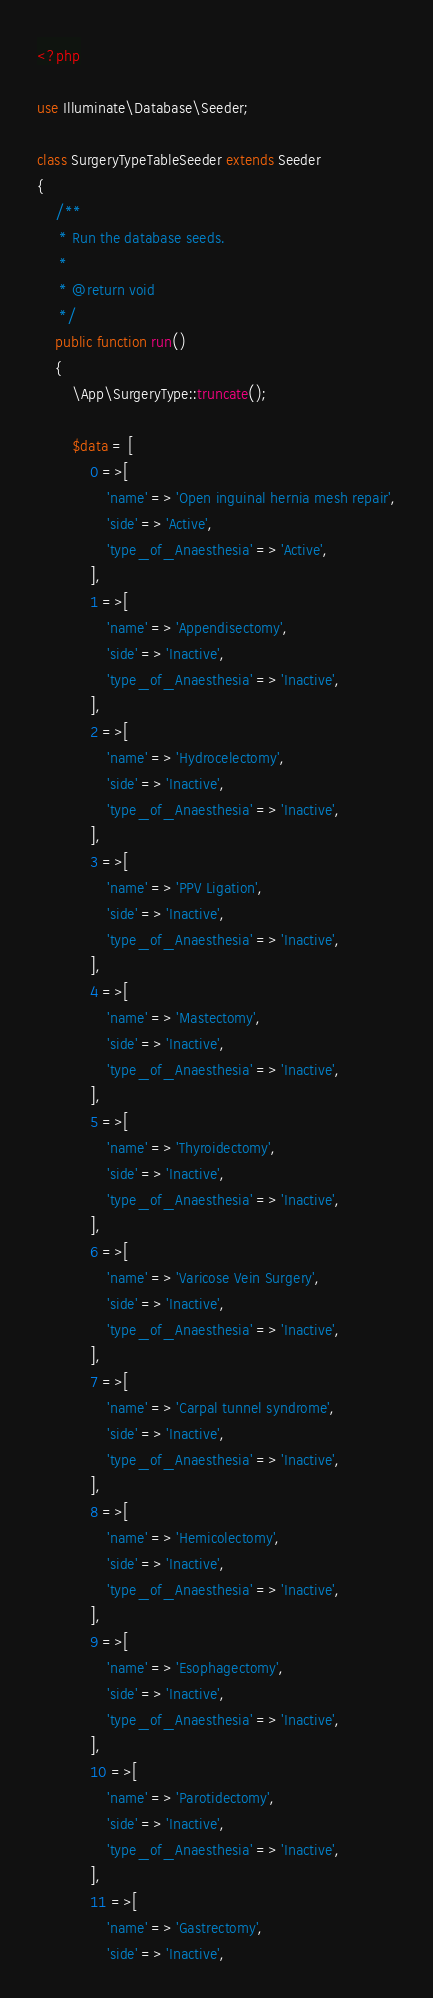<code> <loc_0><loc_0><loc_500><loc_500><_PHP_><?php

use Illuminate\Database\Seeder;

class SurgeryTypeTableSeeder extends Seeder
{
    /**
     * Run the database seeds.
     *
     * @return void
     */
    public function run()
    {
        \App\SurgeryType::truncate();

        $data = [
            0 =>[
                'name' => 'Open inguinal hernia mesh repair',
                'side' => 'Active',
                'type_of_Anaesthesia' => 'Active',
            ],
            1 =>[
                'name' => 'Appendisectomy',
                'side' => 'Inactive',
                'type_of_Anaesthesia' => 'Inactive',
            ],
            2 =>[
                'name' => 'Hydrocelectomy',
                'side' => 'Inactive',
                'type_of_Anaesthesia' => 'Inactive',
            ],
            3 =>[
                'name' => 'PPV Ligation',
                'side' => 'Inactive',
                'type_of_Anaesthesia' => 'Inactive',
            ],
            4 =>[
                'name' => 'Mastectomy',
                'side' => 'Inactive',
                'type_of_Anaesthesia' => 'Inactive',
            ],
            5 =>[
                'name' => 'Thyroidectomy',
                'side' => 'Inactive',
                'type_of_Anaesthesia' => 'Inactive',
            ],
            6 =>[
                'name' => 'Varicose Vein Surgery',
                'side' => 'Inactive',
                'type_of_Anaesthesia' => 'Inactive',
            ],
            7 =>[
                'name' => 'Carpal tunnel syndrome',
                'side' => 'Inactive',
                'type_of_Anaesthesia' => 'Inactive',
            ],
            8 =>[
                'name' => 'Hemicolectomy',
                'side' => 'Inactive',
                'type_of_Anaesthesia' => 'Inactive',
            ],
            9 =>[
                'name' => 'Esophagectomy',
                'side' => 'Inactive',
                'type_of_Anaesthesia' => 'Inactive',
            ],
            10 =>[
                'name' => 'Parotidectomy',
                'side' => 'Inactive',
                'type_of_Anaesthesia' => 'Inactive',
            ],
            11 =>[
                'name' => 'Gastrectomy',
                'side' => 'Inactive',</code> 